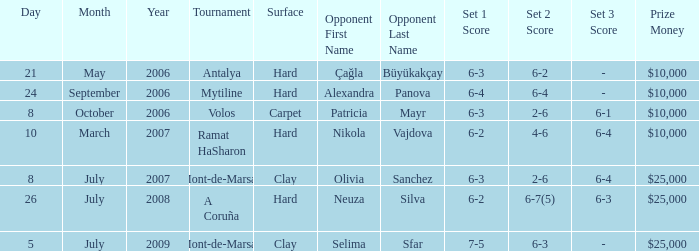Who was the opponent on carpet in a final? Patricia Mayr. 